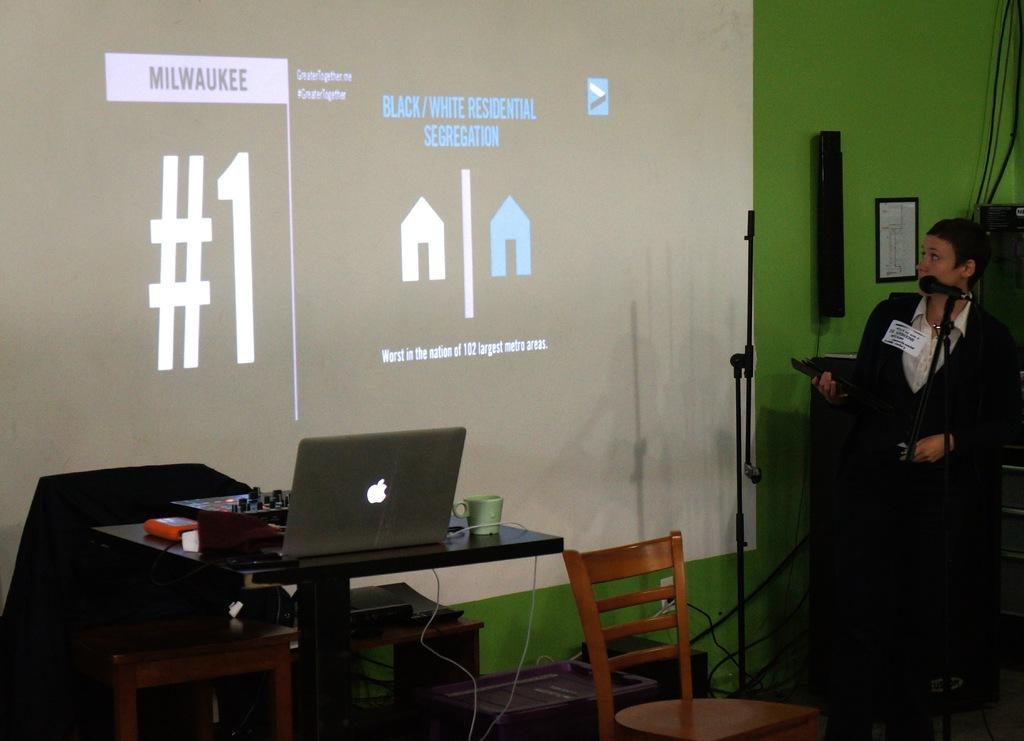In one or two sentences, can you explain what this image depicts? This picture shows a projected screen and man standing and speaking with the help of a microphone and we see a laptop on the table and we see a chair 